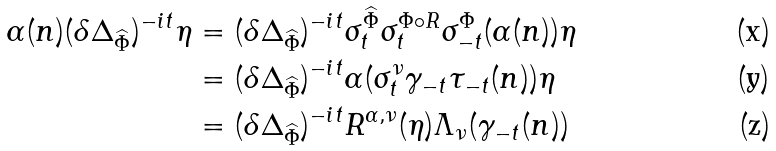<formula> <loc_0><loc_0><loc_500><loc_500>\alpha ( n ) ( \delta \Delta _ { \widehat { \Phi } } ) ^ { - i t } \eta & = ( \delta \Delta _ { \widehat { \Phi } } ) ^ { - i t } \sigma _ { t } ^ { \widehat { \Phi } } \sigma _ { t } ^ { \Phi \circ R } \sigma _ { - t } ^ { \Phi } ( \alpha ( n ) ) \eta \\ & = ( \delta \Delta _ { \widehat { \Phi } } ) ^ { - i t } \alpha ( \sigma ^ { \nu } _ { t } \gamma _ { - t } \tau _ { - t } ( n ) ) \eta \\ & = ( \delta \Delta _ { \widehat { \Phi } } ) ^ { - i t } R ^ { \alpha , \nu } ( \eta ) \Lambda _ { \nu } ( \gamma _ { - t } ( n ) )</formula> 